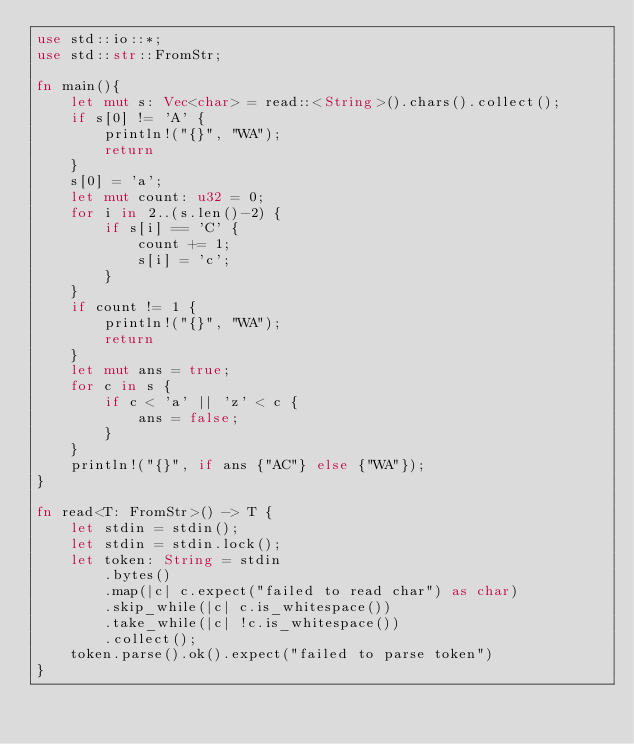Convert code to text. <code><loc_0><loc_0><loc_500><loc_500><_Rust_>use std::io::*;
use std::str::FromStr;

fn main(){
    let mut s: Vec<char> = read::<String>().chars().collect();
    if s[0] != 'A' {
        println!("{}", "WA");
        return
    }
    s[0] = 'a';
    let mut count: u32 = 0;
    for i in 2..(s.len()-2) {
        if s[i] == 'C' {
            count += 1;
            s[i] = 'c';
        }
    }
    if count != 1 {
        println!("{}", "WA");
        return
    }
    let mut ans = true;
    for c in s {
        if c < 'a' || 'z' < c {
            ans = false;
        }
    }
    println!("{}", if ans {"AC"} else {"WA"});
}

fn read<T: FromStr>() -> T {
    let stdin = stdin();
    let stdin = stdin.lock();
    let token: String = stdin
        .bytes()
        .map(|c| c.expect("failed to read char") as char) 
        .skip_while(|c| c.is_whitespace())
        .take_while(|c| !c.is_whitespace())
        .collect();
    token.parse().ok().expect("failed to parse token")
}</code> 